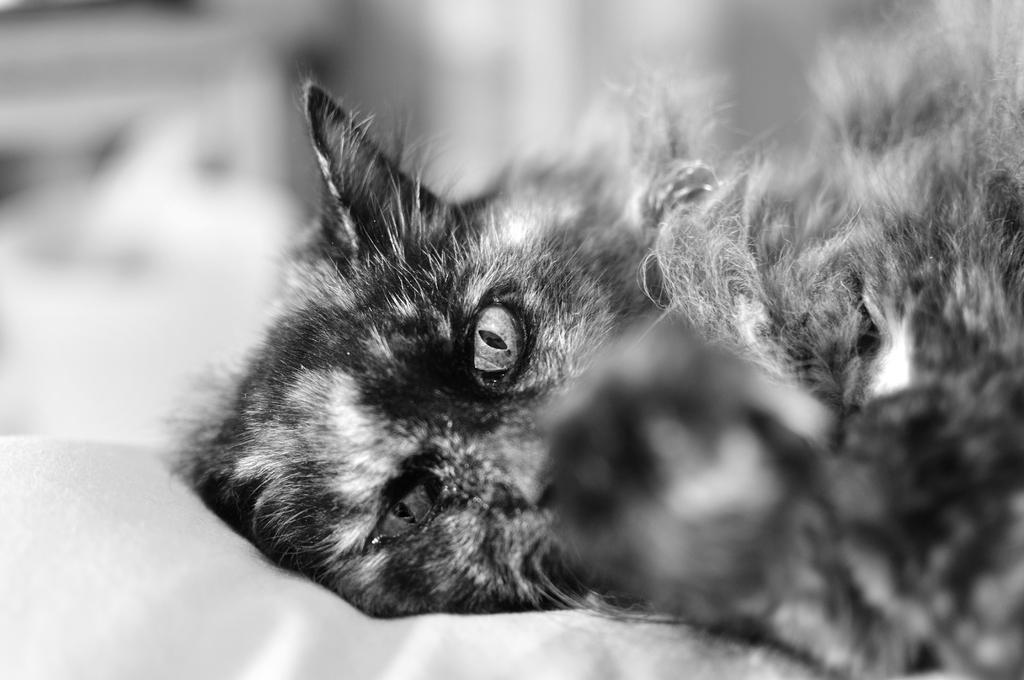Could you give a brief overview of what you see in this image? In this image I can see a cat and I can see this image is black and white in colour. I can also see this image is little bit blurry from background. 